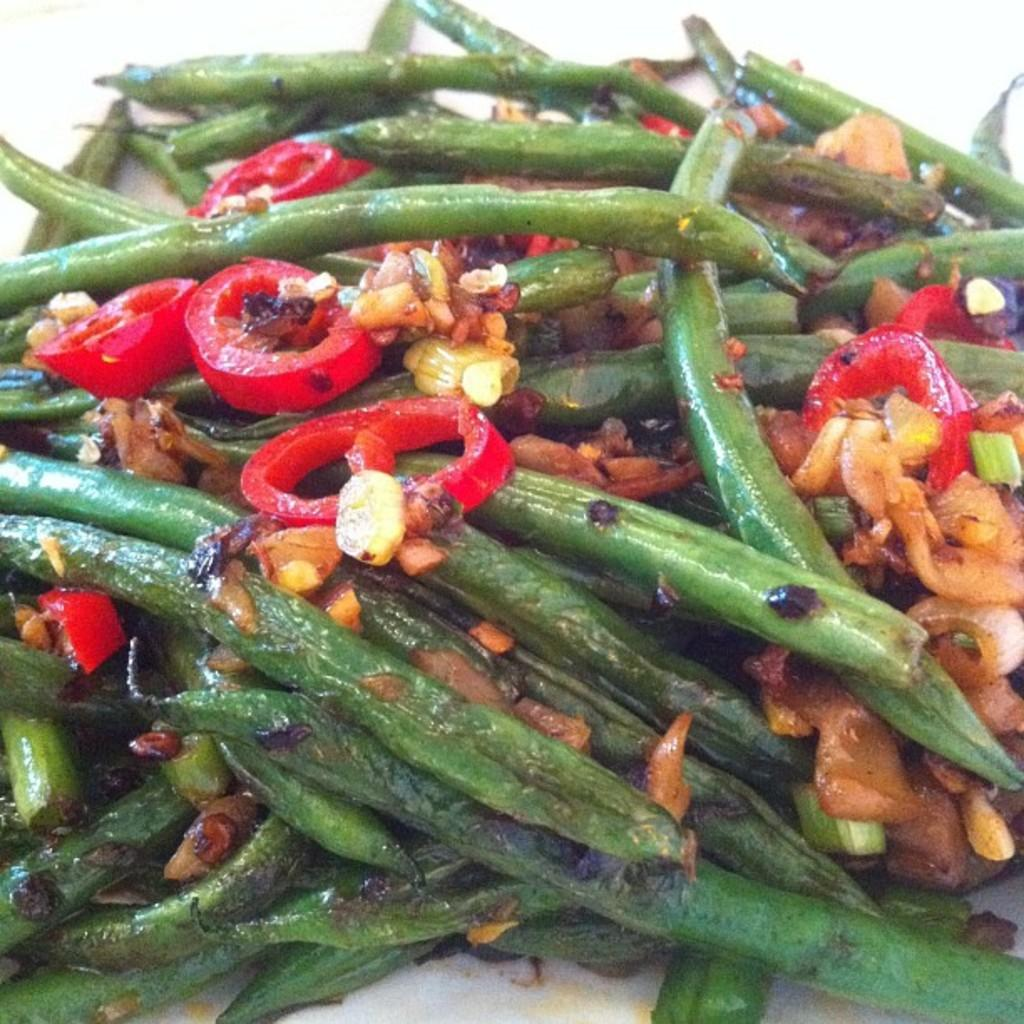What type of food is shown in the image? There are fried veggies in the image. What is the color of the surface the fried veggies are on? The surface they are on is white. What type of selection is available for the giraffe in the image? There is no giraffe present in the image, so there is no selection available for it. 